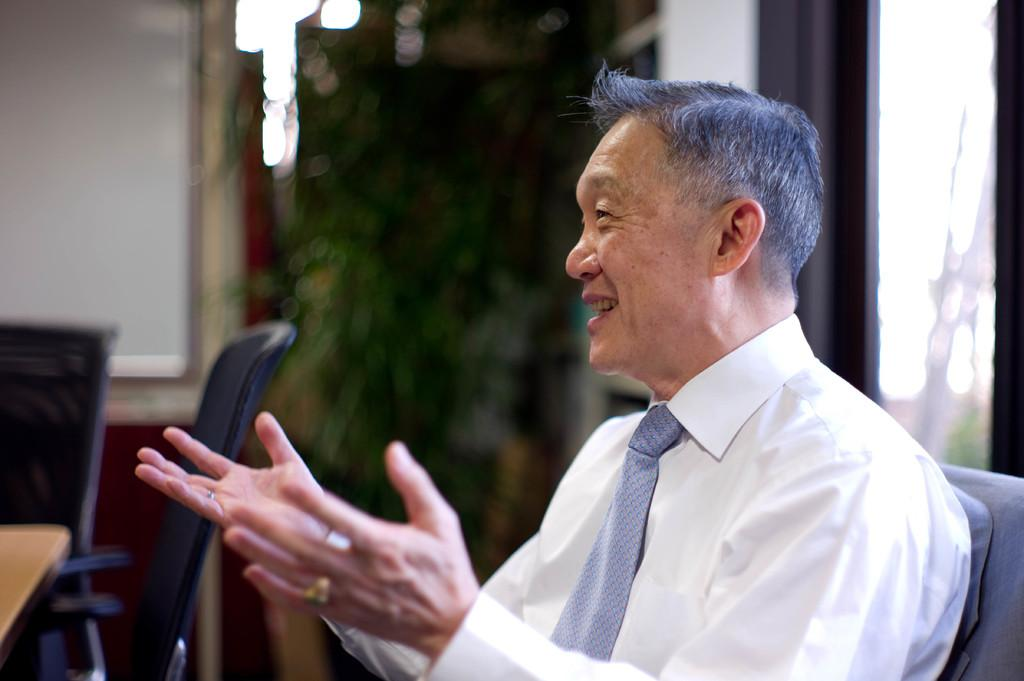Who is present in the image? There is a man in the image. What is the man wearing? The man is wearing a white shirt and a tie. What is the man doing in the image? The man is talking. What else can be seen in the image besides the man? There are empty chairs and a tree in the image. What type of sign is the man holding in the image? There is no sign present in the image; the man is simply talking. What kind of paper is the man using to write on in the image? There is no paper visible in the image, as the man is talking and not writing. 